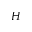Convert formula to latex. <formula><loc_0><loc_0><loc_500><loc_500>H</formula> 